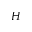Convert formula to latex. <formula><loc_0><loc_0><loc_500><loc_500>H</formula> 